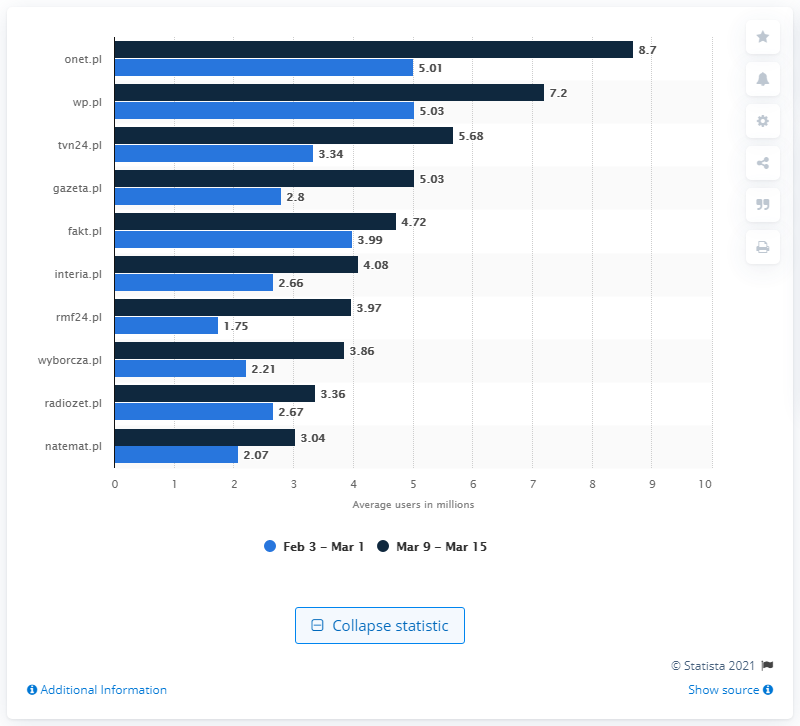Outline some significant characteristics in this image. The news section of RMF24 gained 2.21 viewers during the observed period. 